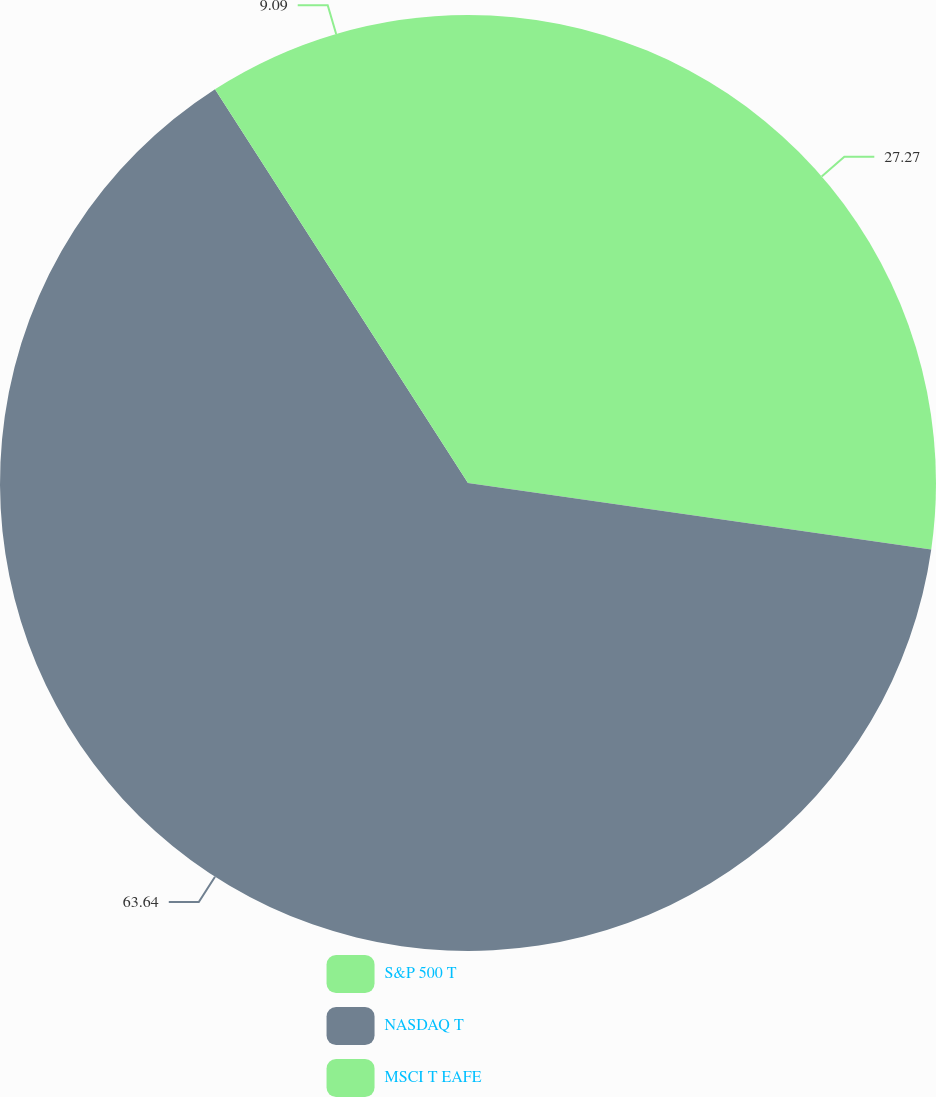<chart> <loc_0><loc_0><loc_500><loc_500><pie_chart><fcel>S&P 500 T<fcel>NASDAQ T<fcel>MSCI T EAFE<nl><fcel>27.27%<fcel>63.64%<fcel>9.09%<nl></chart> 